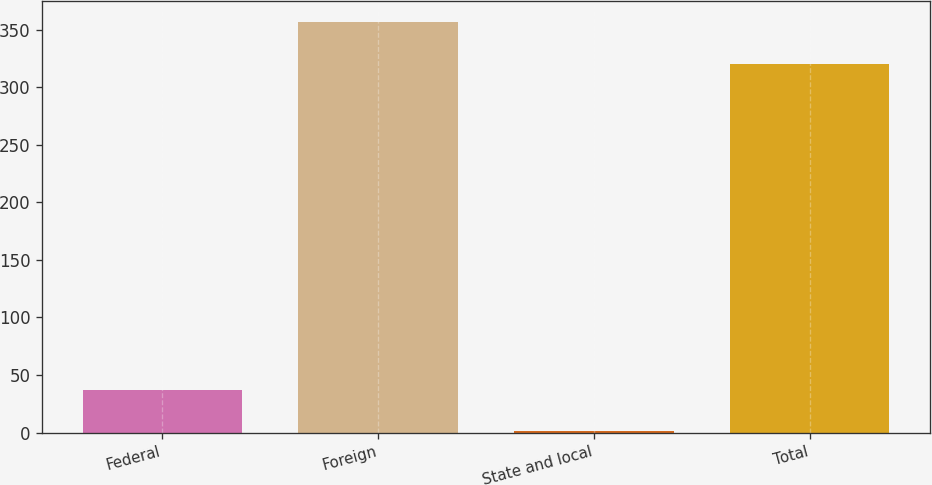<chart> <loc_0><loc_0><loc_500><loc_500><bar_chart><fcel>Federal<fcel>Foreign<fcel>State and local<fcel>Total<nl><fcel>36.6<fcel>357<fcel>1<fcel>320<nl></chart> 